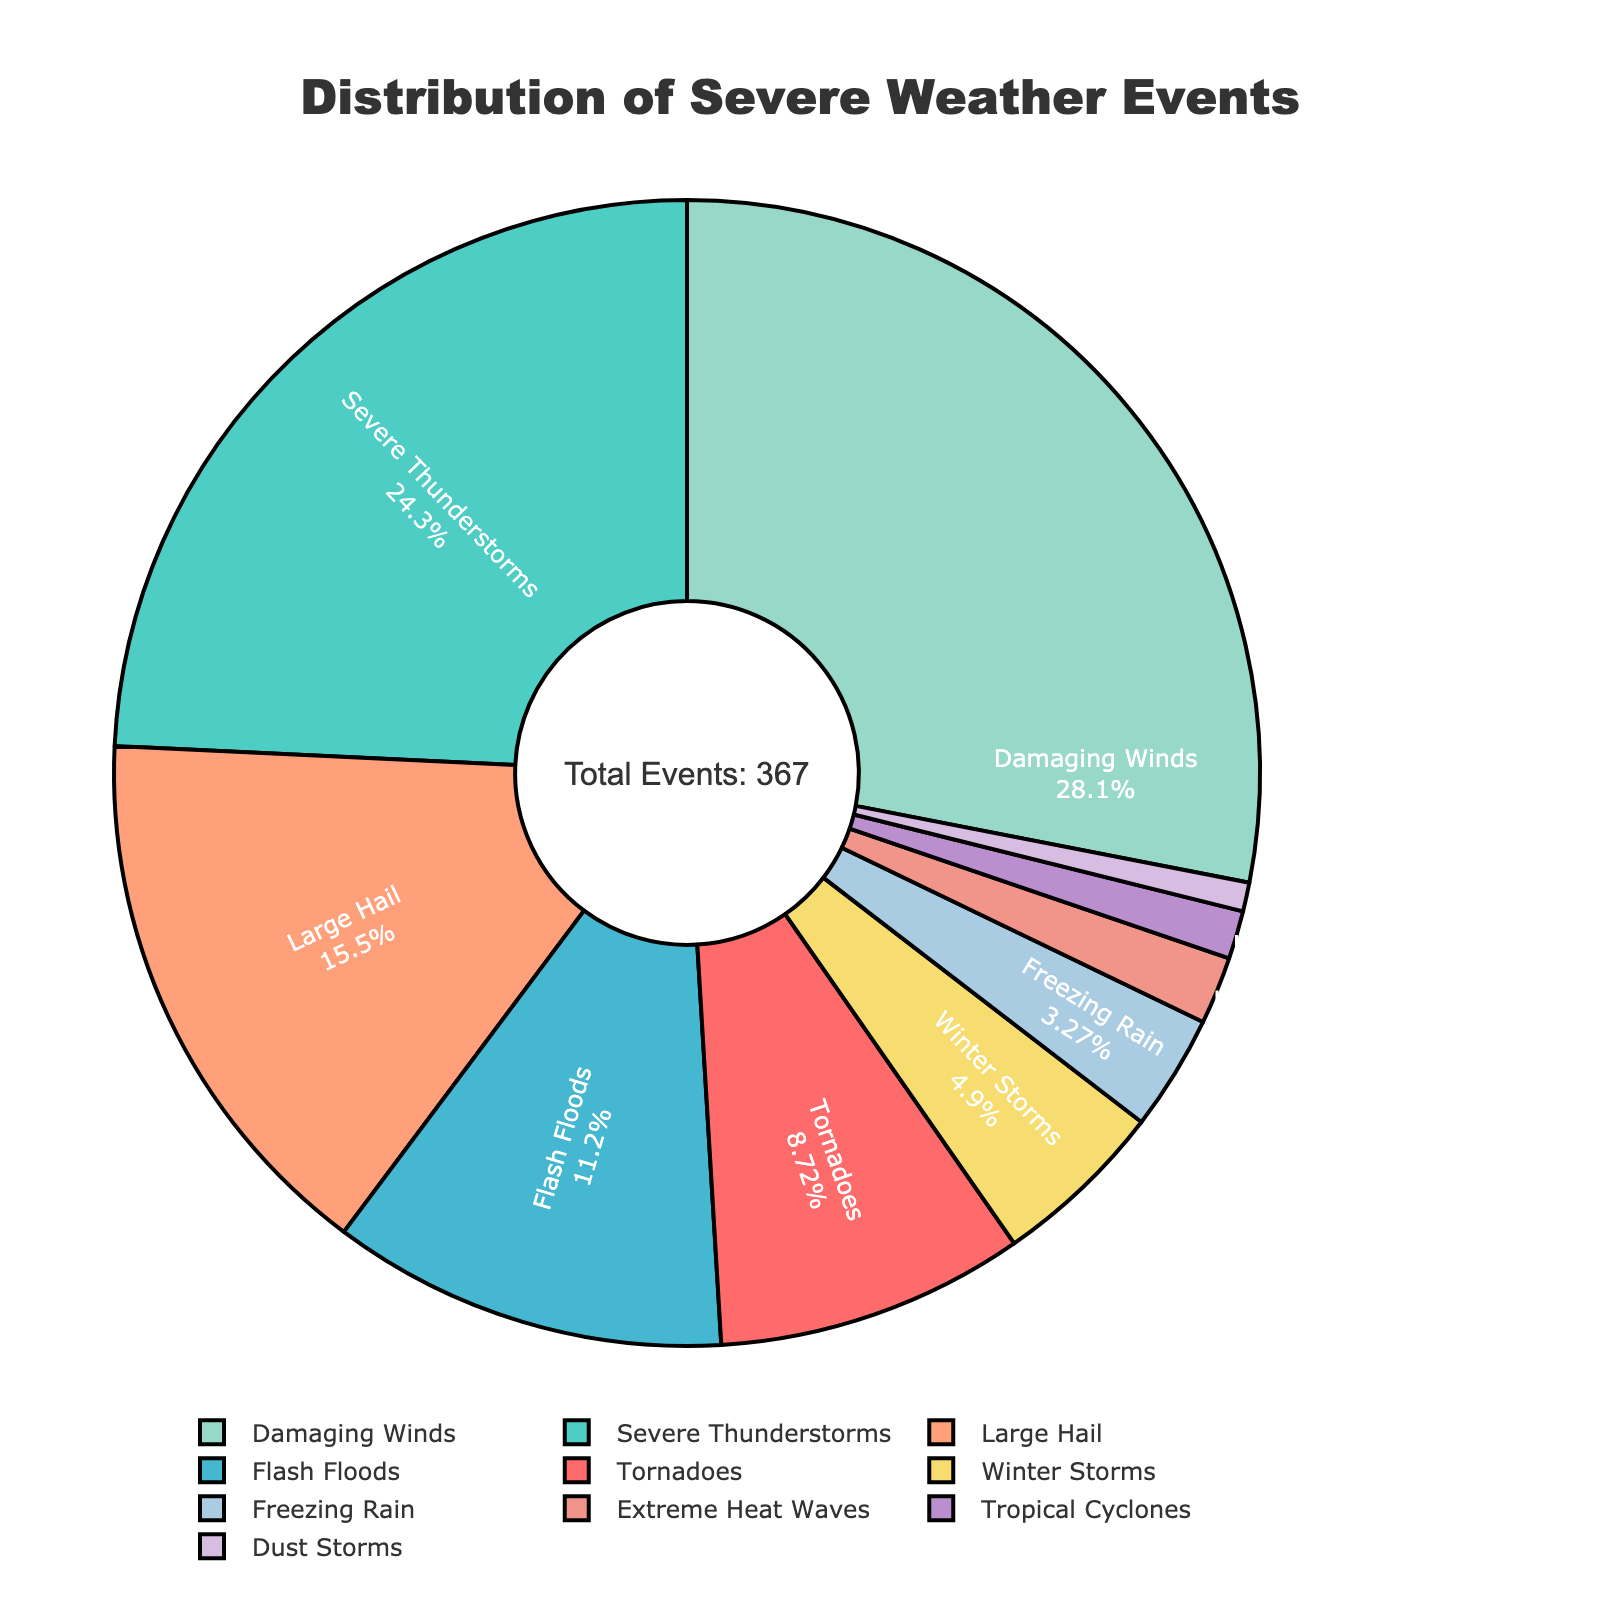What percentage of the total severe weather events were Tornadoes? Identify the segment labeled Tornadoes and note its percentage value displayed on the pie chart
Answer: 9.1% How many more occurrences of Damaging Winds are there compared to Tornadoes? The pie chart shows 103 occurrences of Damaging Winds and 32 occurrences of Tornadoes. Subtract 32 from 103
Answer: 71 Which event type has the smallest percentage and how many occurrences does it have? Identify the smallest segment of the pie chart, which represents Dust Storms, and note the occurrences
Answer: Dust Storms, 3 What is the total number of occurrences of all weather events combined? Refer to the annotation that states the total number of events on the figure
Answer: 367 What is the total percentage of Flash Floods and Freezing Rain combined? Add the percentages of the Flash Floods and Freezing Rain segments displayed on the pie chart
Answer: 11.2% + 3.3% = 14.5% Which event type has a higher occurrence, Large Hail or Severe Thunderstorms, and by how much? Compare the occurrences of Large Hail (57) with Severe Thunderstorms (89). Subtract 57 from 89
Answer: Severe Thunderstorms, 32 What are the colors used for representing Winter Storms and Tropical Cyclones in the pie chart? Observe the colors associated with the segments of Winter Storms and Tropical Cyclones
Answer: Winter Storms: Pinkish-Purple, Tropical Cyclones: Light Purple What percentage of the total weather events do Damaging Winds, Severe Thunderstorms, and Flash Floods make up together? Add the percentages of Damaging Winds, Severe Thunderstorms, and Flash Floods displayed on the pie chart
Answer: 28.1% + 24.2% + 11.2% = 63.5% What is the average number of occurrences for the event types that had fewer than 20 occurrences? Identify the event types with fewer than 20 occurrences (Winter Storms, Tropical Cyclones, Extreme Heat Waves, Dust Storms, Freezing Rain) and calculate the average (18 + 5 + 7 + 3 + 12) / 5
Answer: 9 What is the difference in the number of occurrences between the least common event type and the most common event type? Compare the occurrences of the least common event (Dust Storms, 3) with the most common event (Damaging Winds, 103). Subtract 3 from 103
Answer: 100 